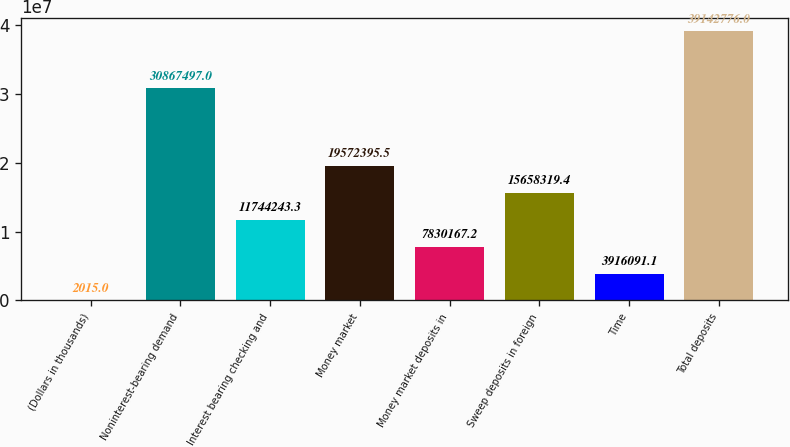Convert chart. <chart><loc_0><loc_0><loc_500><loc_500><bar_chart><fcel>(Dollars in thousands)<fcel>Noninterest-bearing demand<fcel>Interest bearing checking and<fcel>Money market<fcel>Money market deposits in<fcel>Sweep deposits in foreign<fcel>Time<fcel>Total deposits<nl><fcel>2015<fcel>3.08675e+07<fcel>1.17442e+07<fcel>1.95724e+07<fcel>7.83017e+06<fcel>1.56583e+07<fcel>3.91609e+06<fcel>3.91428e+07<nl></chart> 